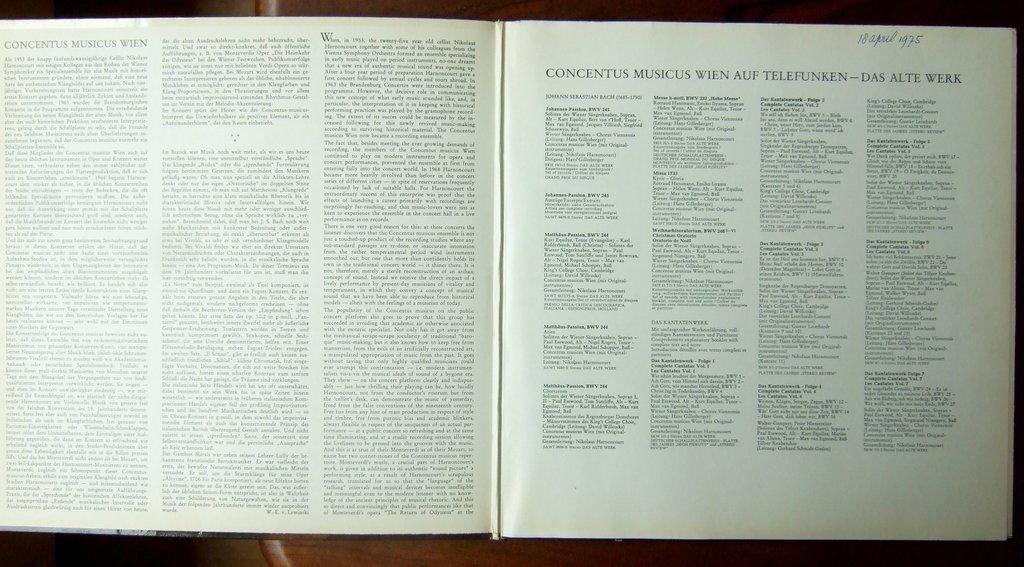<image>
Share a concise interpretation of the image provided. Concentus Musicus Wien is the title of the chapter of this open book. 